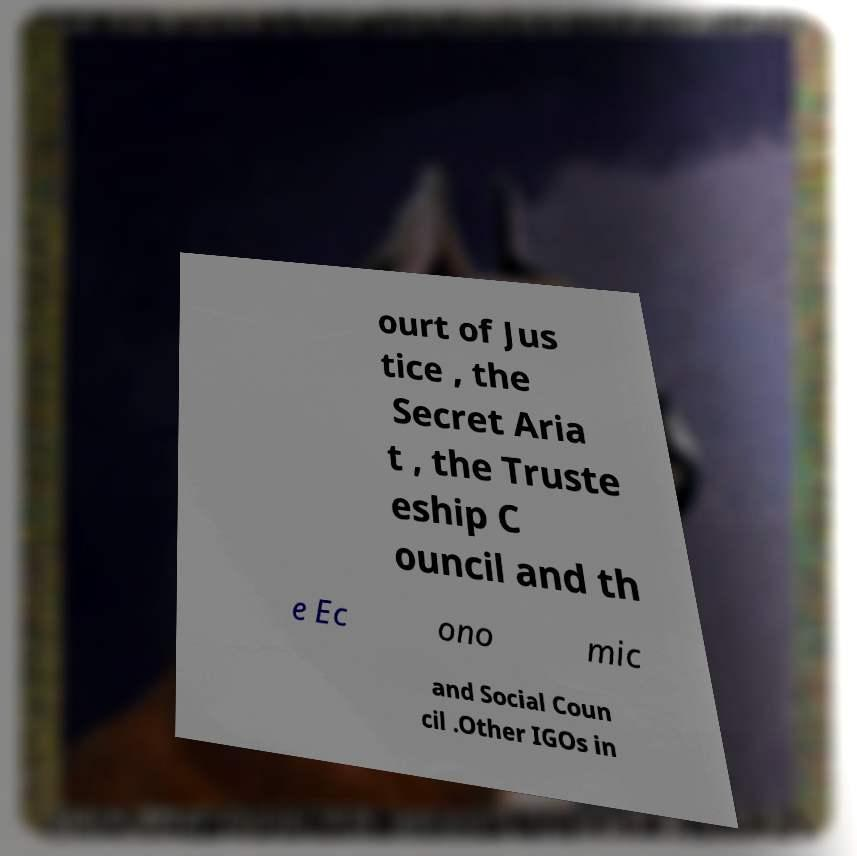Please identify and transcribe the text found in this image. ourt of Jus tice , the Secret Aria t , the Truste eship C ouncil and th e Ec ono mic and Social Coun cil .Other IGOs in 